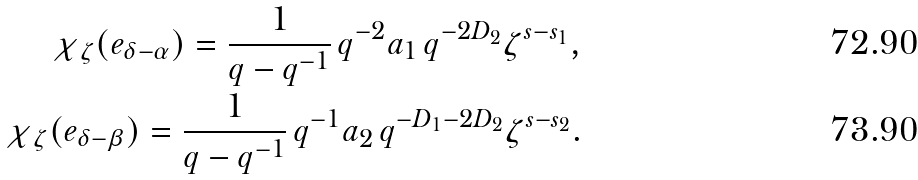Convert formula to latex. <formula><loc_0><loc_0><loc_500><loc_500>\chi _ { \zeta } ( e _ { \delta - \alpha } ) = \frac { 1 } { q - q ^ { - 1 } } \, q ^ { - 2 } a _ { 1 } \, q ^ { - 2 D _ { 2 } } \zeta ^ { s - s _ { 1 } } , \\ \chi _ { \zeta } ( e _ { \delta - \beta } ) = \frac { 1 } { q - q ^ { - 1 } } \, q ^ { - 1 } a _ { 2 } \, q ^ { - D _ { 1 } - 2 D _ { 2 } } \zeta ^ { s - s _ { 2 } } .</formula> 